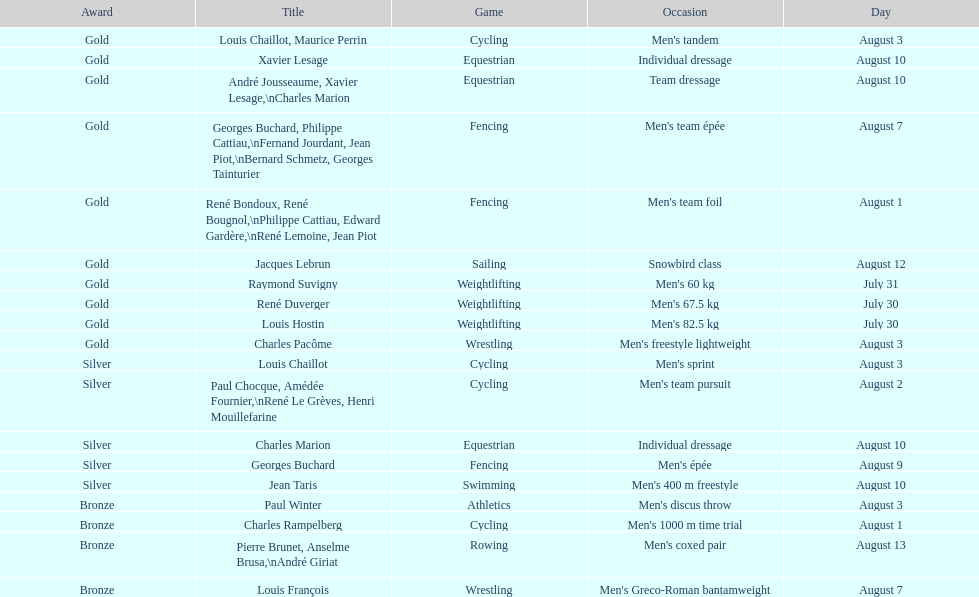Was there more gold medals won than silver? Yes. 